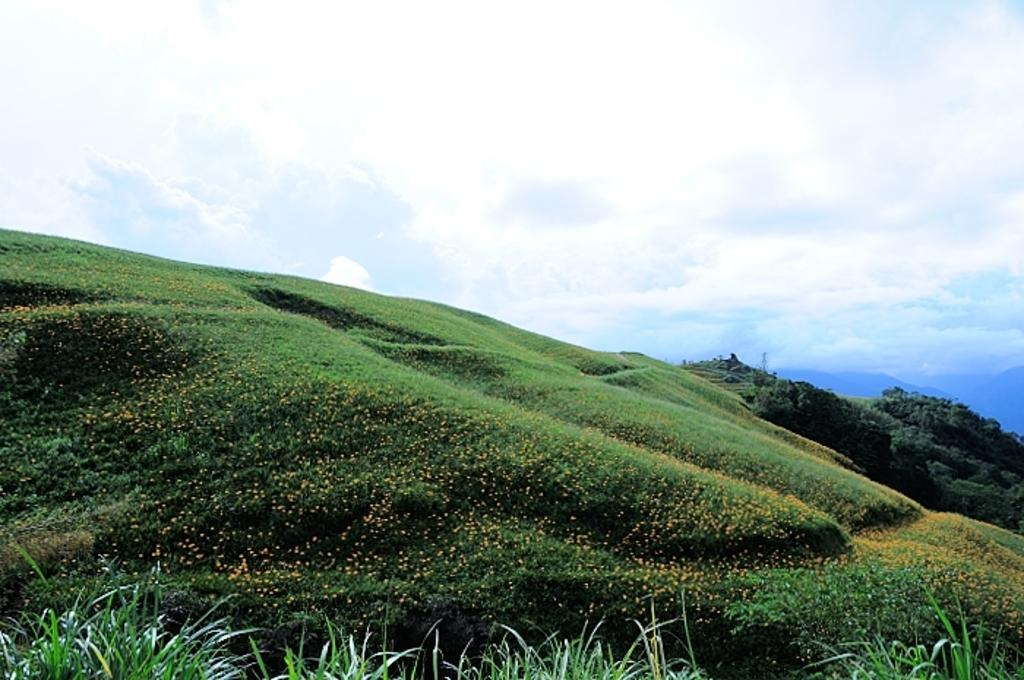What type of vegetation can be seen in the image? There is grass and plants with flowers in the image. Where are the plants located in the image? The plants are on the ground. What can be seen in the background of the image? There are clouds, trees, and mountains in the background of the image. Where is the market located in the image? There is no market present in the image. What type of lock is used to secure the trees in the image? There are no locks present in the image, and the trees are not secured. 